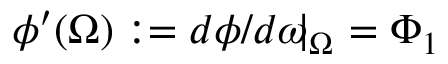<formula> <loc_0><loc_0><loc_500><loc_500>\phi ^ { \prime } ( \Omega ) \colon = d \phi / d \omega \, | _ { \Omega } \, = \Phi _ { 1 }</formula> 